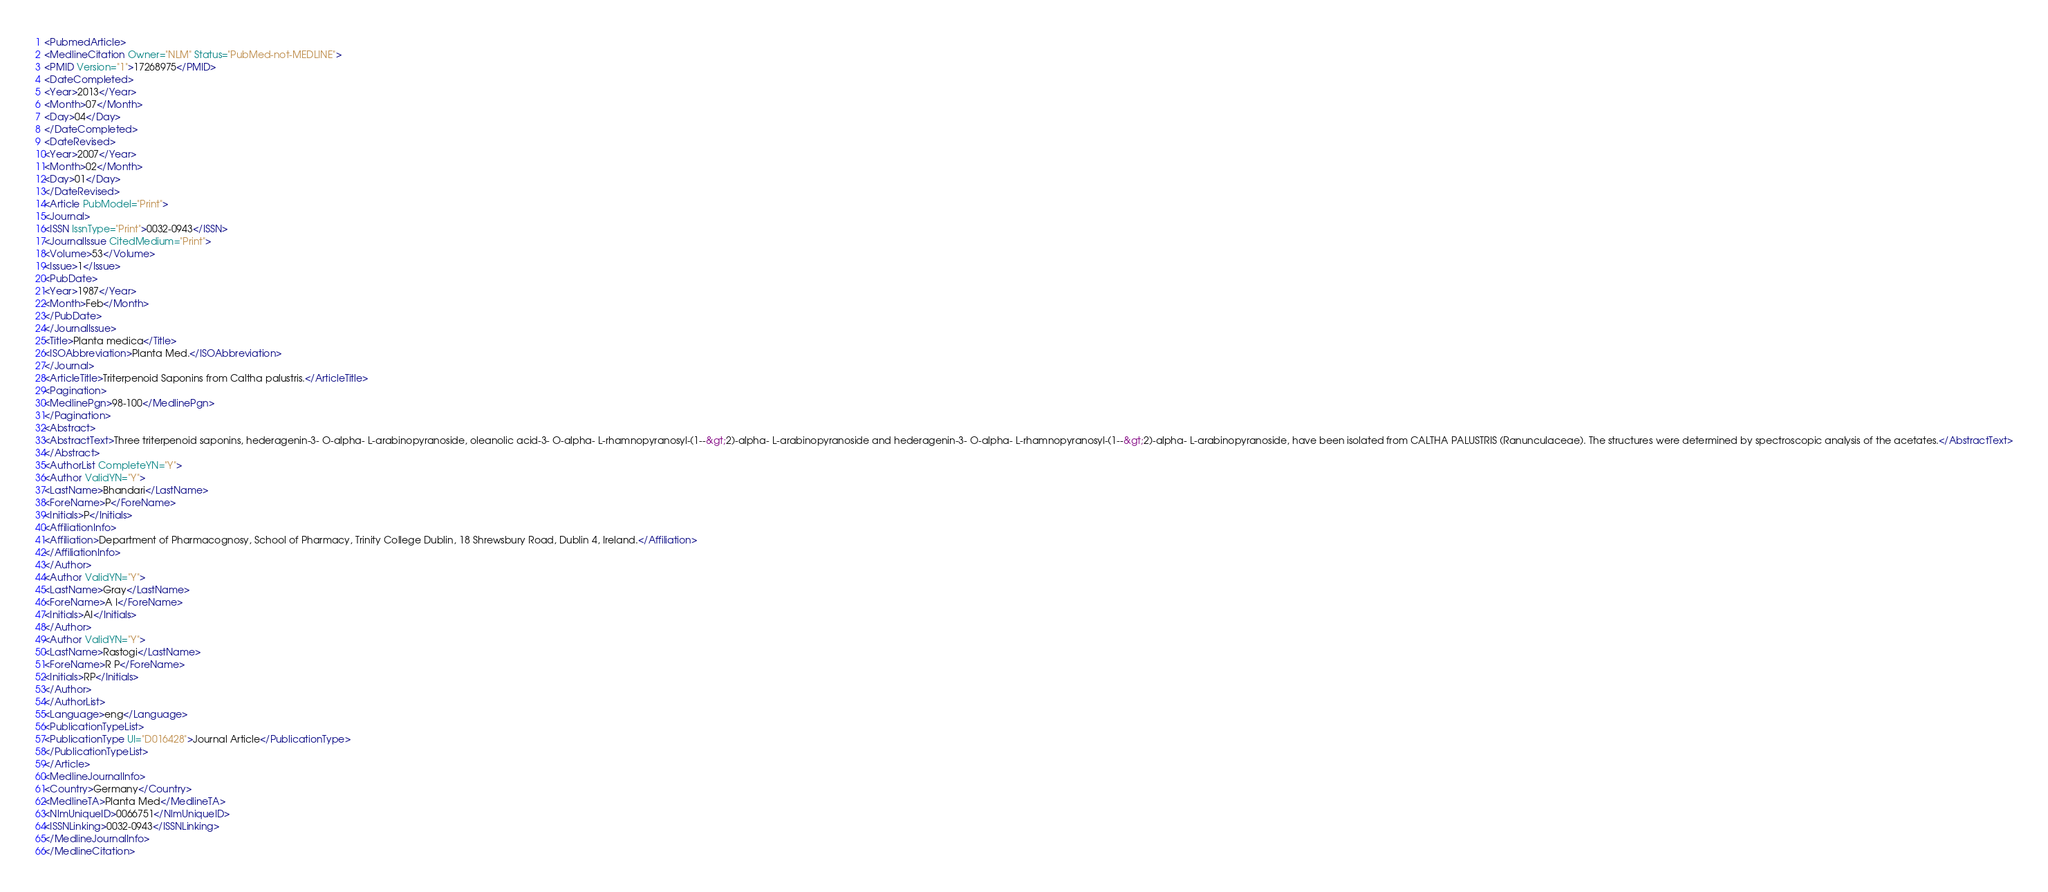<code> <loc_0><loc_0><loc_500><loc_500><_XML_><PubmedArticle>
<MedlineCitation Owner="NLM" Status="PubMed-not-MEDLINE">
<PMID Version="1">17268975</PMID>
<DateCompleted>
<Year>2013</Year>
<Month>07</Month>
<Day>04</Day>
</DateCompleted>
<DateRevised>
<Year>2007</Year>
<Month>02</Month>
<Day>01</Day>
</DateRevised>
<Article PubModel="Print">
<Journal>
<ISSN IssnType="Print">0032-0943</ISSN>
<JournalIssue CitedMedium="Print">
<Volume>53</Volume>
<Issue>1</Issue>
<PubDate>
<Year>1987</Year>
<Month>Feb</Month>
</PubDate>
</JournalIssue>
<Title>Planta medica</Title>
<ISOAbbreviation>Planta Med.</ISOAbbreviation>
</Journal>
<ArticleTitle>Triterpenoid Saponins from Caltha palustris.</ArticleTitle>
<Pagination>
<MedlinePgn>98-100</MedlinePgn>
</Pagination>
<Abstract>
<AbstractText>Three triterpenoid saponins, hederagenin-3- O-alpha- L-arabinopyranoside, oleanolic acid-3- O-alpha- L-rhamnopyranosyl-(1--&gt;2)-alpha- L-arabinopyranoside and hederagenin-3- O-alpha- L-rhamnopyranosyl-(1--&gt;2)-alpha- L-arabinopyranoside, have been isolated from CALTHA PALUSTRIS (Ranunculaceae). The structures were determined by spectroscopic analysis of the acetates.</AbstractText>
</Abstract>
<AuthorList CompleteYN="Y">
<Author ValidYN="Y">
<LastName>Bhandari</LastName>
<ForeName>P</ForeName>
<Initials>P</Initials>
<AffiliationInfo>
<Affiliation>Department of Pharmacognosy, School of Pharmacy, Trinity College Dublin, 18 Shrewsbury Road, Dublin 4, Ireland.</Affiliation>
</AffiliationInfo>
</Author>
<Author ValidYN="Y">
<LastName>Gray</LastName>
<ForeName>A I</ForeName>
<Initials>AI</Initials>
</Author>
<Author ValidYN="Y">
<LastName>Rastogi</LastName>
<ForeName>R P</ForeName>
<Initials>RP</Initials>
</Author>
</AuthorList>
<Language>eng</Language>
<PublicationTypeList>
<PublicationType UI="D016428">Journal Article</PublicationType>
</PublicationTypeList>
</Article>
<MedlineJournalInfo>
<Country>Germany</Country>
<MedlineTA>Planta Med</MedlineTA>
<NlmUniqueID>0066751</NlmUniqueID>
<ISSNLinking>0032-0943</ISSNLinking>
</MedlineJournalInfo>
</MedlineCitation></code> 